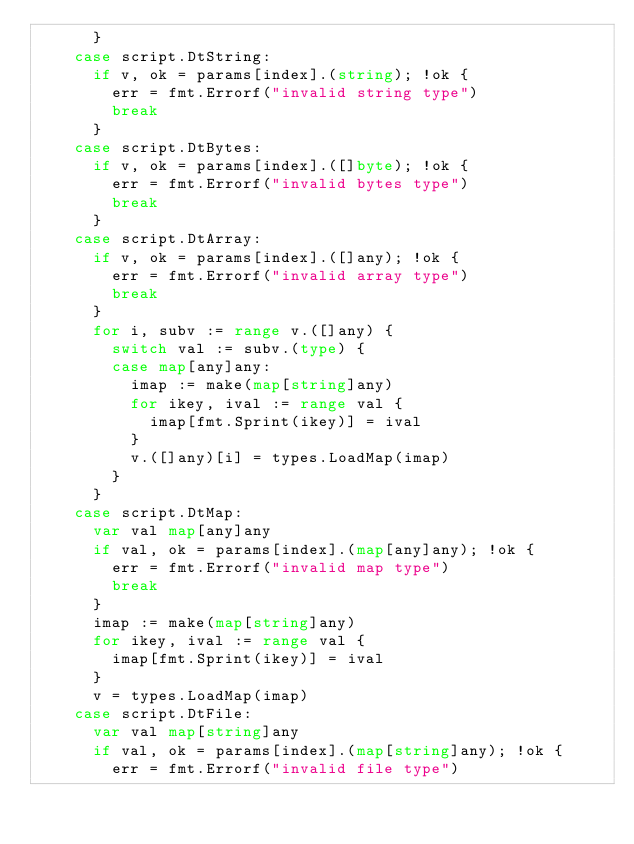Convert code to text. <code><loc_0><loc_0><loc_500><loc_500><_Go_>			}
		case script.DtString:
			if v, ok = params[index].(string); !ok {
				err = fmt.Errorf("invalid string type")
				break
			}
		case script.DtBytes:
			if v, ok = params[index].([]byte); !ok {
				err = fmt.Errorf("invalid bytes type")
				break
			}
		case script.DtArray:
			if v, ok = params[index].([]any); !ok {
				err = fmt.Errorf("invalid array type")
				break
			}
			for i, subv := range v.([]any) {
				switch val := subv.(type) {
				case map[any]any:
					imap := make(map[string]any)
					for ikey, ival := range val {
						imap[fmt.Sprint(ikey)] = ival
					}
					v.([]any)[i] = types.LoadMap(imap)
				}
			}
		case script.DtMap:
			var val map[any]any
			if val, ok = params[index].(map[any]any); !ok {
				err = fmt.Errorf("invalid map type")
				break
			}
			imap := make(map[string]any)
			for ikey, ival := range val {
				imap[fmt.Sprint(ikey)] = ival
			}
			v = types.LoadMap(imap)
		case script.DtFile:
			var val map[string]any
			if val, ok = params[index].(map[string]any); !ok {
				err = fmt.Errorf("invalid file type")</code> 